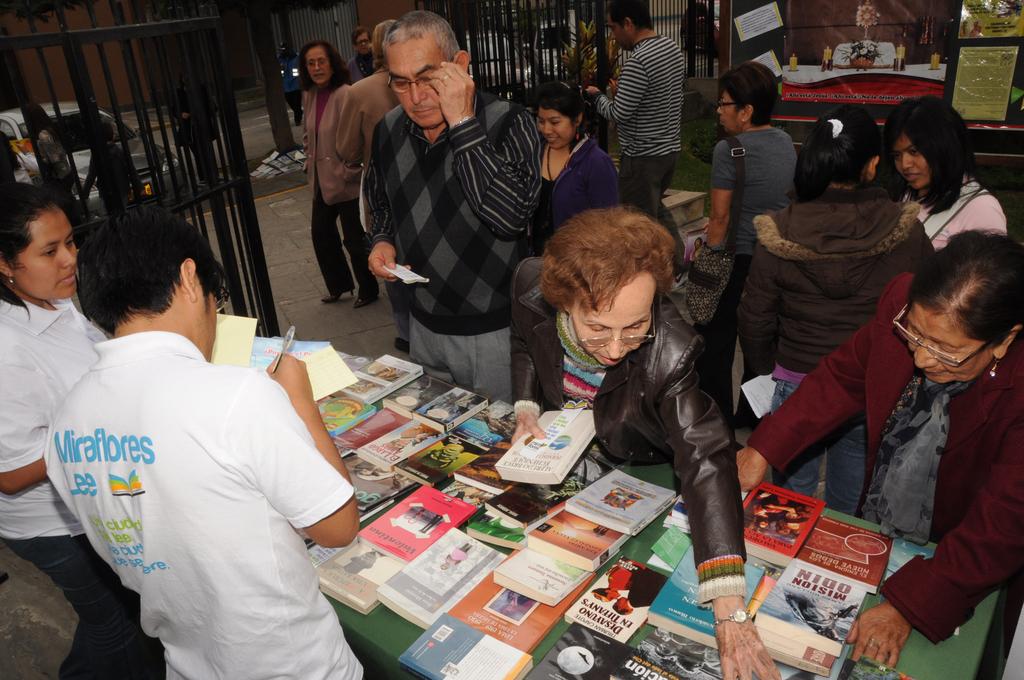What's the first word on the back of the guy's shirt?
Offer a very short reply. Miraflores. What is on the back of the white shirt?
Offer a very short reply. Miraflores. 